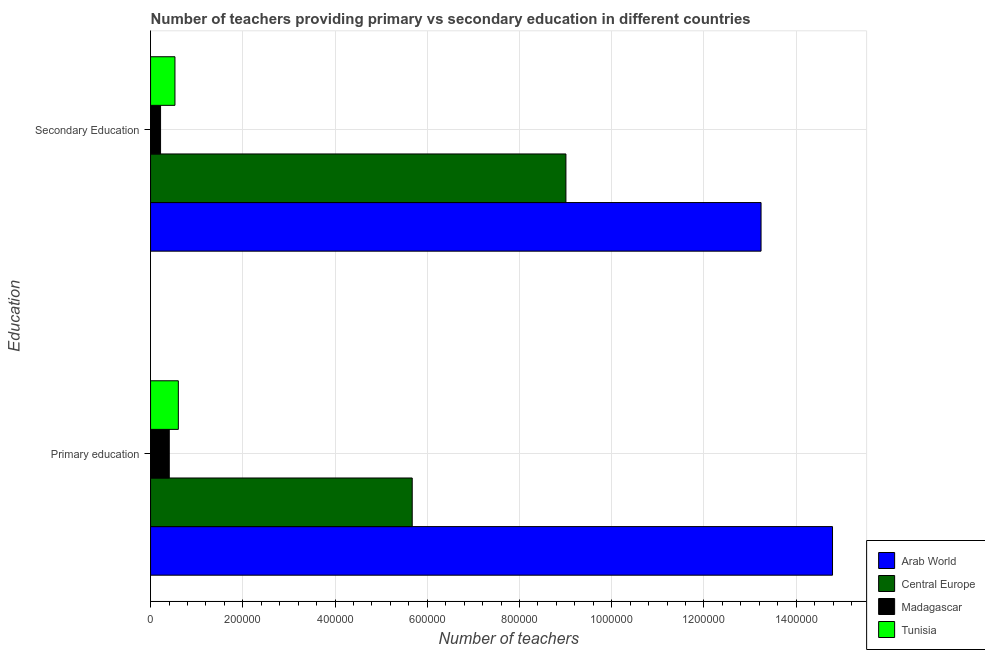How many different coloured bars are there?
Ensure brevity in your answer.  4. How many groups of bars are there?
Keep it short and to the point. 2. Are the number of bars on each tick of the Y-axis equal?
Ensure brevity in your answer.  Yes. How many bars are there on the 2nd tick from the bottom?
Offer a very short reply. 4. What is the label of the 1st group of bars from the top?
Give a very brief answer. Secondary Education. What is the number of secondary teachers in Arab World?
Your response must be concise. 1.32e+06. Across all countries, what is the maximum number of secondary teachers?
Keep it short and to the point. 1.32e+06. Across all countries, what is the minimum number of primary teachers?
Your response must be concise. 4.06e+04. In which country was the number of primary teachers maximum?
Your response must be concise. Arab World. In which country was the number of secondary teachers minimum?
Your response must be concise. Madagascar. What is the total number of secondary teachers in the graph?
Provide a succinct answer. 2.30e+06. What is the difference between the number of secondary teachers in Madagascar and that in Central Europe?
Keep it short and to the point. -8.79e+05. What is the difference between the number of secondary teachers in Central Europe and the number of primary teachers in Tunisia?
Provide a short and direct response. 8.40e+05. What is the average number of secondary teachers per country?
Ensure brevity in your answer.  5.75e+05. What is the difference between the number of secondary teachers and number of primary teachers in Central Europe?
Your answer should be very brief. 3.33e+05. What is the ratio of the number of secondary teachers in Tunisia to that in Arab World?
Provide a succinct answer. 0.04. Is the number of secondary teachers in Tunisia less than that in Arab World?
Your answer should be compact. Yes. What does the 2nd bar from the top in Primary education represents?
Your response must be concise. Madagascar. What does the 1st bar from the bottom in Primary education represents?
Offer a very short reply. Arab World. Are all the bars in the graph horizontal?
Provide a succinct answer. Yes. Are the values on the major ticks of X-axis written in scientific E-notation?
Offer a terse response. No. Does the graph contain any zero values?
Make the answer very short. No. How are the legend labels stacked?
Your answer should be very brief. Vertical. What is the title of the graph?
Make the answer very short. Number of teachers providing primary vs secondary education in different countries. Does "Canada" appear as one of the legend labels in the graph?
Keep it short and to the point. No. What is the label or title of the X-axis?
Offer a very short reply. Number of teachers. What is the label or title of the Y-axis?
Your response must be concise. Education. What is the Number of teachers in Arab World in Primary education?
Give a very brief answer. 1.48e+06. What is the Number of teachers of Central Europe in Primary education?
Ensure brevity in your answer.  5.67e+05. What is the Number of teachers in Madagascar in Primary education?
Your response must be concise. 4.06e+04. What is the Number of teachers in Tunisia in Primary education?
Your response must be concise. 6.02e+04. What is the Number of teachers in Arab World in Secondary Education?
Offer a very short reply. 1.32e+06. What is the Number of teachers in Central Europe in Secondary Education?
Your answer should be compact. 9.01e+05. What is the Number of teachers in Madagascar in Secondary Education?
Your answer should be compact. 2.17e+04. What is the Number of teachers in Tunisia in Secondary Education?
Offer a terse response. 5.29e+04. Across all Education, what is the maximum Number of teachers of Arab World?
Provide a short and direct response. 1.48e+06. Across all Education, what is the maximum Number of teachers of Central Europe?
Make the answer very short. 9.01e+05. Across all Education, what is the maximum Number of teachers of Madagascar?
Make the answer very short. 4.06e+04. Across all Education, what is the maximum Number of teachers of Tunisia?
Your answer should be compact. 6.02e+04. Across all Education, what is the minimum Number of teachers in Arab World?
Offer a terse response. 1.32e+06. Across all Education, what is the minimum Number of teachers in Central Europe?
Your answer should be very brief. 5.67e+05. Across all Education, what is the minimum Number of teachers of Madagascar?
Provide a succinct answer. 2.17e+04. Across all Education, what is the minimum Number of teachers of Tunisia?
Your answer should be very brief. 5.29e+04. What is the total Number of teachers of Arab World in the graph?
Your response must be concise. 2.80e+06. What is the total Number of teachers of Central Europe in the graph?
Offer a terse response. 1.47e+06. What is the total Number of teachers in Madagascar in the graph?
Ensure brevity in your answer.  6.23e+04. What is the total Number of teachers of Tunisia in the graph?
Your response must be concise. 1.13e+05. What is the difference between the Number of teachers in Arab World in Primary education and that in Secondary Education?
Your answer should be very brief. 1.55e+05. What is the difference between the Number of teachers in Central Europe in Primary education and that in Secondary Education?
Make the answer very short. -3.33e+05. What is the difference between the Number of teachers of Madagascar in Primary education and that in Secondary Education?
Keep it short and to the point. 1.89e+04. What is the difference between the Number of teachers of Tunisia in Primary education and that in Secondary Education?
Provide a succinct answer. 7324. What is the difference between the Number of teachers of Arab World in Primary education and the Number of teachers of Central Europe in Secondary Education?
Provide a short and direct response. 5.78e+05. What is the difference between the Number of teachers of Arab World in Primary education and the Number of teachers of Madagascar in Secondary Education?
Your answer should be very brief. 1.46e+06. What is the difference between the Number of teachers of Arab World in Primary education and the Number of teachers of Tunisia in Secondary Education?
Provide a short and direct response. 1.43e+06. What is the difference between the Number of teachers of Central Europe in Primary education and the Number of teachers of Madagascar in Secondary Education?
Keep it short and to the point. 5.46e+05. What is the difference between the Number of teachers of Central Europe in Primary education and the Number of teachers of Tunisia in Secondary Education?
Make the answer very short. 5.14e+05. What is the difference between the Number of teachers in Madagascar in Primary education and the Number of teachers in Tunisia in Secondary Education?
Provide a succinct answer. -1.23e+04. What is the average Number of teachers in Arab World per Education?
Ensure brevity in your answer.  1.40e+06. What is the average Number of teachers of Central Europe per Education?
Make the answer very short. 7.34e+05. What is the average Number of teachers of Madagascar per Education?
Give a very brief answer. 3.11e+04. What is the average Number of teachers in Tunisia per Education?
Provide a short and direct response. 5.66e+04. What is the difference between the Number of teachers of Arab World and Number of teachers of Central Europe in Primary education?
Your response must be concise. 9.11e+05. What is the difference between the Number of teachers in Arab World and Number of teachers in Madagascar in Primary education?
Your answer should be compact. 1.44e+06. What is the difference between the Number of teachers of Arab World and Number of teachers of Tunisia in Primary education?
Offer a very short reply. 1.42e+06. What is the difference between the Number of teachers in Central Europe and Number of teachers in Madagascar in Primary education?
Your answer should be compact. 5.27e+05. What is the difference between the Number of teachers in Central Europe and Number of teachers in Tunisia in Primary education?
Your answer should be compact. 5.07e+05. What is the difference between the Number of teachers of Madagascar and Number of teachers of Tunisia in Primary education?
Keep it short and to the point. -1.96e+04. What is the difference between the Number of teachers in Arab World and Number of teachers in Central Europe in Secondary Education?
Provide a succinct answer. 4.23e+05. What is the difference between the Number of teachers in Arab World and Number of teachers in Madagascar in Secondary Education?
Your answer should be very brief. 1.30e+06. What is the difference between the Number of teachers in Arab World and Number of teachers in Tunisia in Secondary Education?
Make the answer very short. 1.27e+06. What is the difference between the Number of teachers in Central Europe and Number of teachers in Madagascar in Secondary Education?
Provide a succinct answer. 8.79e+05. What is the difference between the Number of teachers of Central Europe and Number of teachers of Tunisia in Secondary Education?
Give a very brief answer. 8.48e+05. What is the difference between the Number of teachers in Madagascar and Number of teachers in Tunisia in Secondary Education?
Give a very brief answer. -3.12e+04. What is the ratio of the Number of teachers in Arab World in Primary education to that in Secondary Education?
Offer a terse response. 1.12. What is the ratio of the Number of teachers of Central Europe in Primary education to that in Secondary Education?
Keep it short and to the point. 0.63. What is the ratio of the Number of teachers of Madagascar in Primary education to that in Secondary Education?
Provide a short and direct response. 1.87. What is the ratio of the Number of teachers of Tunisia in Primary education to that in Secondary Education?
Make the answer very short. 1.14. What is the difference between the highest and the second highest Number of teachers of Arab World?
Offer a terse response. 1.55e+05. What is the difference between the highest and the second highest Number of teachers in Central Europe?
Provide a short and direct response. 3.33e+05. What is the difference between the highest and the second highest Number of teachers of Madagascar?
Offer a terse response. 1.89e+04. What is the difference between the highest and the second highest Number of teachers in Tunisia?
Ensure brevity in your answer.  7324. What is the difference between the highest and the lowest Number of teachers of Arab World?
Offer a terse response. 1.55e+05. What is the difference between the highest and the lowest Number of teachers in Central Europe?
Ensure brevity in your answer.  3.33e+05. What is the difference between the highest and the lowest Number of teachers in Madagascar?
Keep it short and to the point. 1.89e+04. What is the difference between the highest and the lowest Number of teachers of Tunisia?
Give a very brief answer. 7324. 